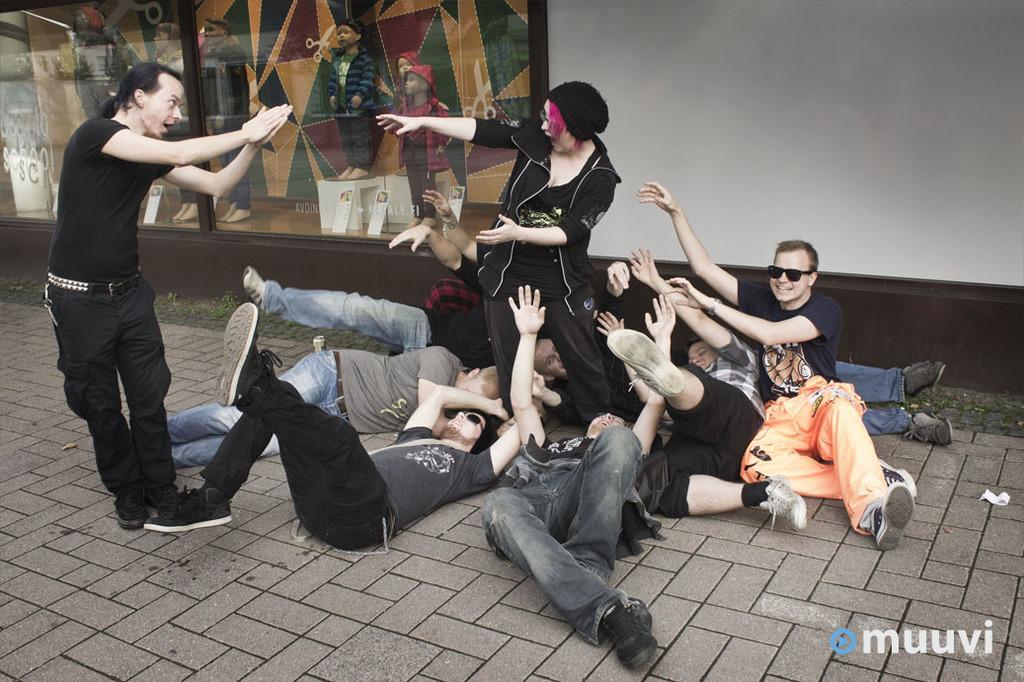Describe this image in one or two sentences. There is a group of persons are lying on the ground at the bottom of this image,There are two persons standing in the middle of this image. There is a wall in the background. There is a glass wall at the top left side of this image. 